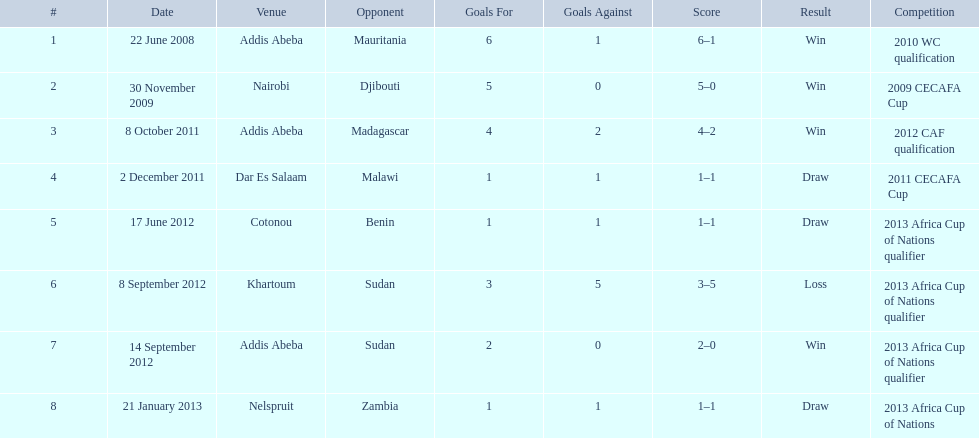How long in years down this table cover? 5. 